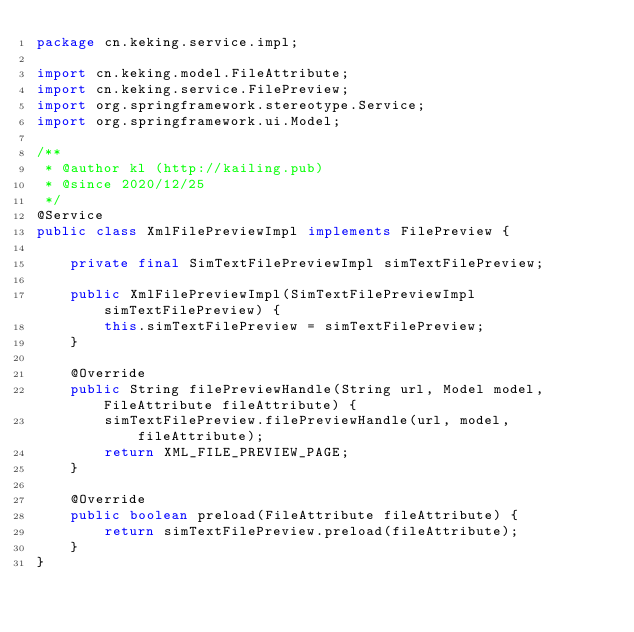<code> <loc_0><loc_0><loc_500><loc_500><_Java_>package cn.keking.service.impl;

import cn.keking.model.FileAttribute;
import cn.keking.service.FilePreview;
import org.springframework.stereotype.Service;
import org.springframework.ui.Model;

/**
 * @author kl (http://kailing.pub)
 * @since 2020/12/25
 */
@Service
public class XmlFilePreviewImpl implements FilePreview {

    private final SimTextFilePreviewImpl simTextFilePreview;

    public XmlFilePreviewImpl(SimTextFilePreviewImpl simTextFilePreview) {
        this.simTextFilePreview = simTextFilePreview;
    }

    @Override
    public String filePreviewHandle(String url, Model model, FileAttribute fileAttribute) {
        simTextFilePreview.filePreviewHandle(url, model, fileAttribute);
        return XML_FILE_PREVIEW_PAGE;
    }

    @Override
    public boolean preload(FileAttribute fileAttribute) {
        return simTextFilePreview.preload(fileAttribute);
    }
}
</code> 